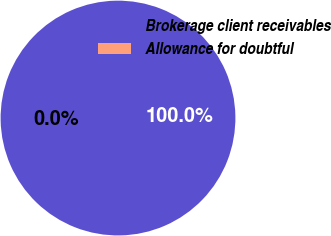<chart> <loc_0><loc_0><loc_500><loc_500><pie_chart><fcel>Brokerage client receivables<fcel>Allowance for doubtful<nl><fcel>100.0%<fcel>0.0%<nl></chart> 